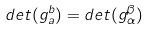Convert formula to latex. <formula><loc_0><loc_0><loc_500><loc_500>d e t ( g _ { a } ^ { b } ) = d e t ( g _ { \alpha } ^ { \beta } )</formula> 